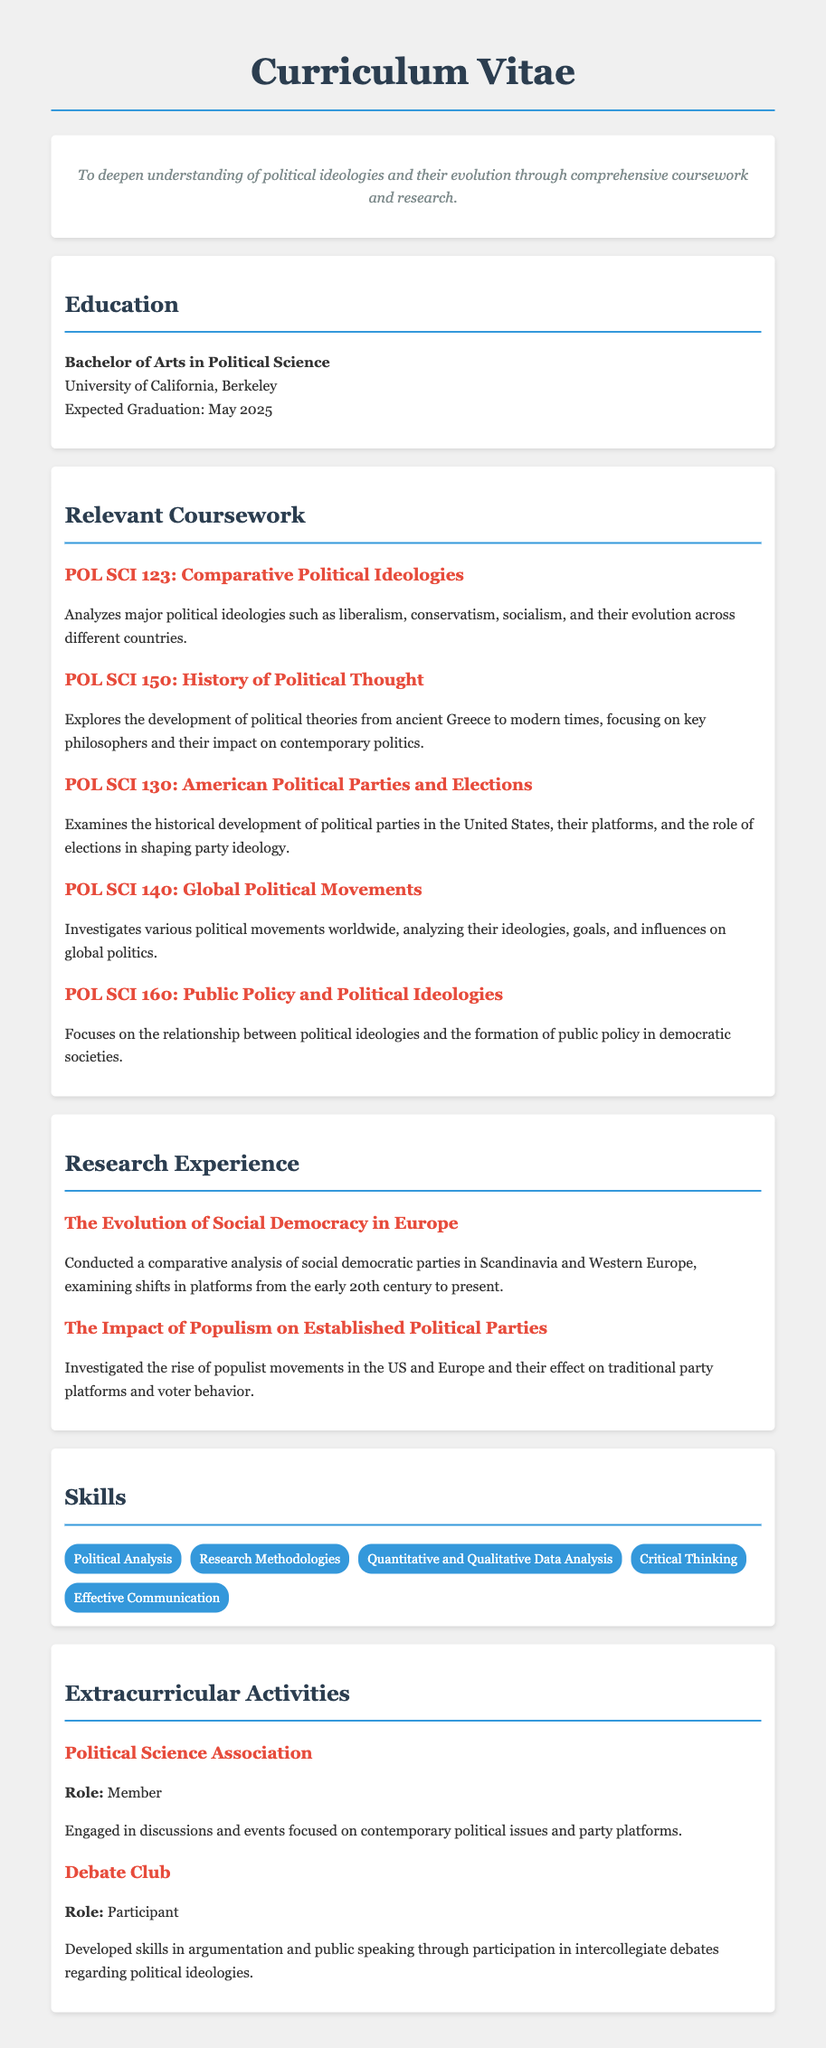what is the degree being pursued? The degree being pursued is specified in the education section of the CV, which states "Bachelor of Arts in Political Science."
Answer: Bachelor of Arts in Political Science when is the expected graduation date? The expected graduation date is mentioned in the education section, and it is "May 2025."
Answer: May 2025 what is the title of the first relevant coursework? The first relevant course listed under coursework is "POL SCI 123: Comparative Political Ideologies."
Answer: POL SCI 123: Comparative Political Ideologies how many research items are listed in the research experience section? The research experience section lists two research items, indicating the amount of research experience included in the CV.
Answer: 2 what skill includes analysis of data? One of the skills listed explicitly mentions "Quantitative and Qualitative Data Analysis," which involves analysis of data.
Answer: Quantitative and Qualitative Data Analysis what organization is mentioned under extracurricular activities? The extracurricular activities section mentions the "Political Science Association."
Answer: Political Science Association which course focuses on public policy? The course that focuses on public policy is "POL SCI 160: Public Policy and Political Ideologies."
Answer: POL SCI 160: Public Policy and Political Ideologies who is the target audience for this CV? The target audience for the CV is implied through the objectives and educational background, suggesting it is aimed at potential employers or graduate programs in political science.
Answer: Potential employers or graduate programs what political aspect is analyzed in POL SCI 130? POL SCI 130 examines the "historical development of political parties" in the United States.
Answer: historical development of political parties 